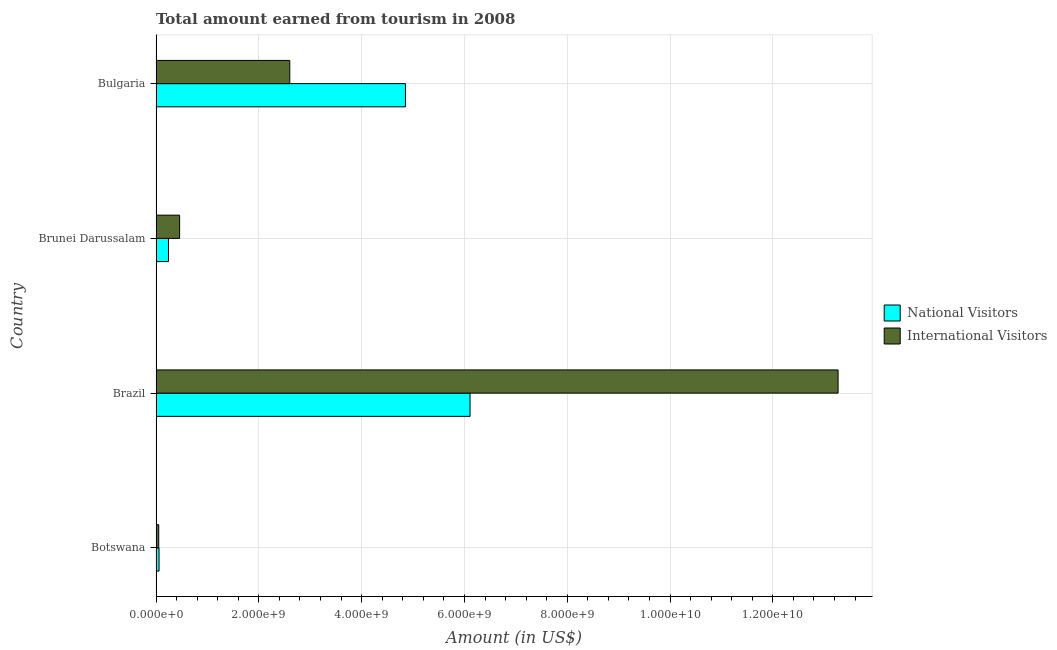How many groups of bars are there?
Make the answer very short. 4. Are the number of bars per tick equal to the number of legend labels?
Offer a very short reply. Yes. How many bars are there on the 1st tick from the bottom?
Offer a terse response. 2. What is the amount earned from national visitors in Brazil?
Keep it short and to the point. 6.11e+09. Across all countries, what is the maximum amount earned from international visitors?
Provide a succinct answer. 1.33e+1. Across all countries, what is the minimum amount earned from international visitors?
Provide a succinct answer. 5.27e+07. In which country was the amount earned from national visitors minimum?
Offer a very short reply. Botswana. What is the total amount earned from national visitors in the graph?
Ensure brevity in your answer.  1.13e+1. What is the difference between the amount earned from international visitors in Brazil and that in Bulgaria?
Your response must be concise. 1.07e+1. What is the difference between the amount earned from international visitors in Brazil and the amount earned from national visitors in Brunei Darussalam?
Offer a very short reply. 1.30e+1. What is the average amount earned from national visitors per country?
Your answer should be very brief. 2.82e+09. What is the difference between the amount earned from national visitors and amount earned from international visitors in Brunei Darussalam?
Give a very brief answer. -2.17e+08. What is the ratio of the amount earned from international visitors in Brunei Darussalam to that in Bulgaria?
Your answer should be very brief. 0.18. Is the difference between the amount earned from international visitors in Brazil and Brunei Darussalam greater than the difference between the amount earned from national visitors in Brazil and Brunei Darussalam?
Offer a very short reply. Yes. What is the difference between the highest and the second highest amount earned from international visitors?
Provide a short and direct response. 1.07e+1. What is the difference between the highest and the lowest amount earned from international visitors?
Provide a short and direct response. 1.32e+1. What does the 1st bar from the top in Brazil represents?
Ensure brevity in your answer.  International Visitors. What does the 2nd bar from the bottom in Botswana represents?
Make the answer very short. International Visitors. Does the graph contain any zero values?
Your answer should be compact. No. Where does the legend appear in the graph?
Ensure brevity in your answer.  Center right. How are the legend labels stacked?
Keep it short and to the point. Vertical. What is the title of the graph?
Your answer should be compact. Total amount earned from tourism in 2008. Does "External balance on goods" appear as one of the legend labels in the graph?
Your answer should be very brief. No. What is the label or title of the X-axis?
Provide a short and direct response. Amount (in US$). What is the Amount (in US$) in National Visitors in Botswana?
Ensure brevity in your answer.  5.87e+07. What is the Amount (in US$) in International Visitors in Botswana?
Your response must be concise. 5.27e+07. What is the Amount (in US$) of National Visitors in Brazil?
Give a very brief answer. 6.11e+09. What is the Amount (in US$) in International Visitors in Brazil?
Keep it short and to the point. 1.33e+1. What is the Amount (in US$) in National Visitors in Brunei Darussalam?
Your response must be concise. 2.42e+08. What is the Amount (in US$) of International Visitors in Brunei Darussalam?
Keep it short and to the point. 4.59e+08. What is the Amount (in US$) of National Visitors in Bulgaria?
Your answer should be compact. 4.85e+09. What is the Amount (in US$) of International Visitors in Bulgaria?
Keep it short and to the point. 2.60e+09. Across all countries, what is the maximum Amount (in US$) of National Visitors?
Offer a very short reply. 6.11e+09. Across all countries, what is the maximum Amount (in US$) of International Visitors?
Provide a succinct answer. 1.33e+1. Across all countries, what is the minimum Amount (in US$) in National Visitors?
Make the answer very short. 5.87e+07. Across all countries, what is the minimum Amount (in US$) of International Visitors?
Make the answer very short. 5.27e+07. What is the total Amount (in US$) in National Visitors in the graph?
Keep it short and to the point. 1.13e+1. What is the total Amount (in US$) of International Visitors in the graph?
Keep it short and to the point. 1.64e+1. What is the difference between the Amount (in US$) in National Visitors in Botswana and that in Brazil?
Your answer should be compact. -6.05e+09. What is the difference between the Amount (in US$) in International Visitors in Botswana and that in Brazil?
Keep it short and to the point. -1.32e+1. What is the difference between the Amount (in US$) in National Visitors in Botswana and that in Brunei Darussalam?
Keep it short and to the point. -1.83e+08. What is the difference between the Amount (in US$) of International Visitors in Botswana and that in Brunei Darussalam?
Give a very brief answer. -4.06e+08. What is the difference between the Amount (in US$) of National Visitors in Botswana and that in Bulgaria?
Offer a very short reply. -4.79e+09. What is the difference between the Amount (in US$) of International Visitors in Botswana and that in Bulgaria?
Give a very brief answer. -2.55e+09. What is the difference between the Amount (in US$) in National Visitors in Brazil and that in Brunei Darussalam?
Your response must be concise. 5.87e+09. What is the difference between the Amount (in US$) in International Visitors in Brazil and that in Brunei Darussalam?
Offer a terse response. 1.28e+1. What is the difference between the Amount (in US$) in National Visitors in Brazil and that in Bulgaria?
Make the answer very short. 1.26e+09. What is the difference between the Amount (in US$) of International Visitors in Brazil and that in Bulgaria?
Offer a terse response. 1.07e+1. What is the difference between the Amount (in US$) in National Visitors in Brunei Darussalam and that in Bulgaria?
Offer a terse response. -4.61e+09. What is the difference between the Amount (in US$) of International Visitors in Brunei Darussalam and that in Bulgaria?
Your answer should be compact. -2.14e+09. What is the difference between the Amount (in US$) of National Visitors in Botswana and the Amount (in US$) of International Visitors in Brazil?
Offer a terse response. -1.32e+1. What is the difference between the Amount (in US$) of National Visitors in Botswana and the Amount (in US$) of International Visitors in Brunei Darussalam?
Ensure brevity in your answer.  -4.00e+08. What is the difference between the Amount (in US$) of National Visitors in Botswana and the Amount (in US$) of International Visitors in Bulgaria?
Keep it short and to the point. -2.54e+09. What is the difference between the Amount (in US$) of National Visitors in Brazil and the Amount (in US$) of International Visitors in Brunei Darussalam?
Give a very brief answer. 5.65e+09. What is the difference between the Amount (in US$) in National Visitors in Brazil and the Amount (in US$) in International Visitors in Bulgaria?
Offer a very short reply. 3.51e+09. What is the difference between the Amount (in US$) of National Visitors in Brunei Darussalam and the Amount (in US$) of International Visitors in Bulgaria?
Ensure brevity in your answer.  -2.36e+09. What is the average Amount (in US$) of National Visitors per country?
Make the answer very short. 2.82e+09. What is the average Amount (in US$) of International Visitors per country?
Offer a terse response. 4.10e+09. What is the difference between the Amount (in US$) of National Visitors and Amount (in US$) of International Visitors in Brazil?
Offer a very short reply. -7.16e+09. What is the difference between the Amount (in US$) in National Visitors and Amount (in US$) in International Visitors in Brunei Darussalam?
Keep it short and to the point. -2.17e+08. What is the difference between the Amount (in US$) of National Visitors and Amount (in US$) of International Visitors in Bulgaria?
Offer a very short reply. 2.25e+09. What is the ratio of the Amount (in US$) of National Visitors in Botswana to that in Brazil?
Give a very brief answer. 0.01. What is the ratio of the Amount (in US$) in International Visitors in Botswana to that in Brazil?
Give a very brief answer. 0. What is the ratio of the Amount (in US$) in National Visitors in Botswana to that in Brunei Darussalam?
Keep it short and to the point. 0.24. What is the ratio of the Amount (in US$) of International Visitors in Botswana to that in Brunei Darussalam?
Offer a very short reply. 0.11. What is the ratio of the Amount (in US$) in National Visitors in Botswana to that in Bulgaria?
Your answer should be compact. 0.01. What is the ratio of the Amount (in US$) of International Visitors in Botswana to that in Bulgaria?
Give a very brief answer. 0.02. What is the ratio of the Amount (in US$) of National Visitors in Brazil to that in Brunei Darussalam?
Give a very brief answer. 25.24. What is the ratio of the Amount (in US$) in International Visitors in Brazil to that in Brunei Darussalam?
Provide a succinct answer. 28.91. What is the ratio of the Amount (in US$) of National Visitors in Brazil to that in Bulgaria?
Provide a short and direct response. 1.26. What is the ratio of the Amount (in US$) in International Visitors in Brazil to that in Bulgaria?
Offer a terse response. 5.1. What is the ratio of the Amount (in US$) in National Visitors in Brunei Darussalam to that in Bulgaria?
Give a very brief answer. 0.05. What is the ratio of the Amount (in US$) in International Visitors in Brunei Darussalam to that in Bulgaria?
Make the answer very short. 0.18. What is the difference between the highest and the second highest Amount (in US$) in National Visitors?
Provide a short and direct response. 1.26e+09. What is the difference between the highest and the second highest Amount (in US$) in International Visitors?
Your answer should be compact. 1.07e+1. What is the difference between the highest and the lowest Amount (in US$) of National Visitors?
Keep it short and to the point. 6.05e+09. What is the difference between the highest and the lowest Amount (in US$) of International Visitors?
Your answer should be very brief. 1.32e+1. 